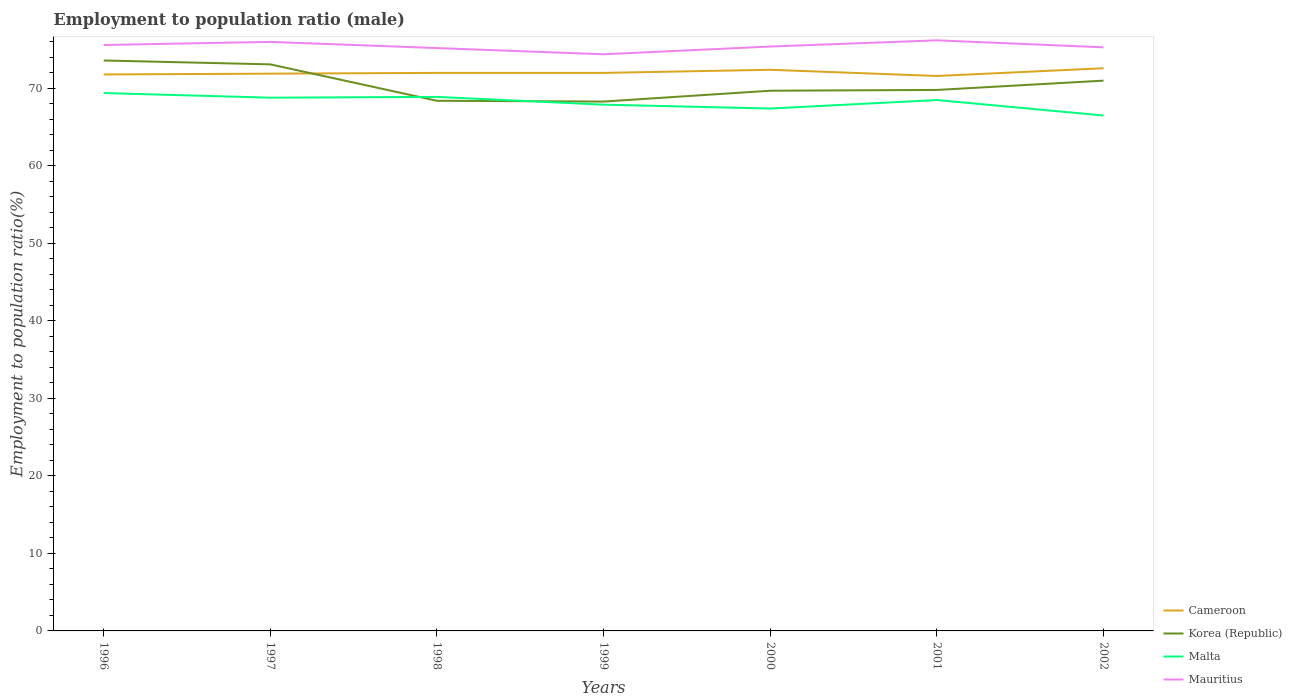How many different coloured lines are there?
Keep it short and to the point. 4. Is the number of lines equal to the number of legend labels?
Your response must be concise. Yes. Across all years, what is the maximum employment to population ratio in Malta?
Your answer should be very brief. 66.5. What is the total employment to population ratio in Mauritius in the graph?
Your answer should be compact. 0.9. What is the difference between the highest and the lowest employment to population ratio in Korea (Republic)?
Your answer should be compact. 3. What is the difference between two consecutive major ticks on the Y-axis?
Provide a succinct answer. 10. Are the values on the major ticks of Y-axis written in scientific E-notation?
Offer a very short reply. No. Does the graph contain any zero values?
Your answer should be very brief. No. Does the graph contain grids?
Provide a short and direct response. No. Where does the legend appear in the graph?
Your answer should be compact. Bottom right. What is the title of the graph?
Offer a very short reply. Employment to population ratio (male). Does "Dominica" appear as one of the legend labels in the graph?
Ensure brevity in your answer.  No. What is the label or title of the X-axis?
Offer a terse response. Years. What is the Employment to population ratio(%) in Cameroon in 1996?
Your response must be concise. 71.8. What is the Employment to population ratio(%) of Korea (Republic) in 1996?
Your answer should be very brief. 73.6. What is the Employment to population ratio(%) of Malta in 1996?
Your answer should be very brief. 69.4. What is the Employment to population ratio(%) of Mauritius in 1996?
Your answer should be very brief. 75.6. What is the Employment to population ratio(%) of Cameroon in 1997?
Ensure brevity in your answer.  71.9. What is the Employment to population ratio(%) of Korea (Republic) in 1997?
Offer a terse response. 73.1. What is the Employment to population ratio(%) in Malta in 1997?
Provide a short and direct response. 68.8. What is the Employment to population ratio(%) of Mauritius in 1997?
Offer a terse response. 76. What is the Employment to population ratio(%) of Cameroon in 1998?
Offer a very short reply. 72. What is the Employment to population ratio(%) in Korea (Republic) in 1998?
Keep it short and to the point. 68.4. What is the Employment to population ratio(%) in Malta in 1998?
Offer a very short reply. 68.9. What is the Employment to population ratio(%) in Mauritius in 1998?
Make the answer very short. 75.2. What is the Employment to population ratio(%) in Korea (Republic) in 1999?
Give a very brief answer. 68.3. What is the Employment to population ratio(%) of Malta in 1999?
Offer a very short reply. 67.9. What is the Employment to population ratio(%) in Mauritius in 1999?
Offer a terse response. 74.4. What is the Employment to population ratio(%) of Cameroon in 2000?
Ensure brevity in your answer.  72.4. What is the Employment to population ratio(%) in Korea (Republic) in 2000?
Give a very brief answer. 69.7. What is the Employment to population ratio(%) in Malta in 2000?
Your response must be concise. 67.4. What is the Employment to population ratio(%) in Mauritius in 2000?
Make the answer very short. 75.4. What is the Employment to population ratio(%) in Cameroon in 2001?
Ensure brevity in your answer.  71.6. What is the Employment to population ratio(%) of Korea (Republic) in 2001?
Your answer should be compact. 69.8. What is the Employment to population ratio(%) in Malta in 2001?
Your answer should be compact. 68.5. What is the Employment to population ratio(%) of Mauritius in 2001?
Give a very brief answer. 76.2. What is the Employment to population ratio(%) of Cameroon in 2002?
Your response must be concise. 72.6. What is the Employment to population ratio(%) of Malta in 2002?
Provide a succinct answer. 66.5. What is the Employment to population ratio(%) in Mauritius in 2002?
Make the answer very short. 75.3. Across all years, what is the maximum Employment to population ratio(%) of Cameroon?
Your response must be concise. 72.6. Across all years, what is the maximum Employment to population ratio(%) of Korea (Republic)?
Give a very brief answer. 73.6. Across all years, what is the maximum Employment to population ratio(%) in Malta?
Give a very brief answer. 69.4. Across all years, what is the maximum Employment to population ratio(%) of Mauritius?
Give a very brief answer. 76.2. Across all years, what is the minimum Employment to population ratio(%) of Cameroon?
Keep it short and to the point. 71.6. Across all years, what is the minimum Employment to population ratio(%) of Korea (Republic)?
Your answer should be compact. 68.3. Across all years, what is the minimum Employment to population ratio(%) in Malta?
Your answer should be very brief. 66.5. Across all years, what is the minimum Employment to population ratio(%) of Mauritius?
Your answer should be very brief. 74.4. What is the total Employment to population ratio(%) in Cameroon in the graph?
Offer a very short reply. 504.3. What is the total Employment to population ratio(%) of Korea (Republic) in the graph?
Give a very brief answer. 493.9. What is the total Employment to population ratio(%) in Malta in the graph?
Provide a short and direct response. 477.4. What is the total Employment to population ratio(%) of Mauritius in the graph?
Provide a succinct answer. 528.1. What is the difference between the Employment to population ratio(%) of Cameroon in 1996 and that in 1997?
Your answer should be compact. -0.1. What is the difference between the Employment to population ratio(%) of Mauritius in 1996 and that in 1997?
Offer a very short reply. -0.4. What is the difference between the Employment to population ratio(%) in Cameroon in 1996 and that in 1998?
Keep it short and to the point. -0.2. What is the difference between the Employment to population ratio(%) in Malta in 1996 and that in 1998?
Give a very brief answer. 0.5. What is the difference between the Employment to population ratio(%) of Mauritius in 1996 and that in 1998?
Provide a succinct answer. 0.4. What is the difference between the Employment to population ratio(%) in Cameroon in 1996 and that in 2001?
Provide a succinct answer. 0.2. What is the difference between the Employment to population ratio(%) of Malta in 1996 and that in 2001?
Your response must be concise. 0.9. What is the difference between the Employment to population ratio(%) of Mauritius in 1996 and that in 2001?
Offer a terse response. -0.6. What is the difference between the Employment to population ratio(%) in Malta in 1996 and that in 2002?
Your response must be concise. 2.9. What is the difference between the Employment to population ratio(%) in Cameroon in 1997 and that in 1998?
Offer a terse response. -0.1. What is the difference between the Employment to population ratio(%) of Malta in 1997 and that in 1998?
Offer a very short reply. -0.1. What is the difference between the Employment to population ratio(%) of Cameroon in 1997 and that in 1999?
Offer a very short reply. -0.1. What is the difference between the Employment to population ratio(%) of Korea (Republic) in 1997 and that in 1999?
Provide a short and direct response. 4.8. What is the difference between the Employment to population ratio(%) in Mauritius in 1997 and that in 1999?
Your response must be concise. 1.6. What is the difference between the Employment to population ratio(%) in Cameroon in 1997 and that in 2000?
Your answer should be compact. -0.5. What is the difference between the Employment to population ratio(%) in Malta in 1997 and that in 2000?
Make the answer very short. 1.4. What is the difference between the Employment to population ratio(%) of Korea (Republic) in 1997 and that in 2001?
Ensure brevity in your answer.  3.3. What is the difference between the Employment to population ratio(%) in Malta in 1997 and that in 2001?
Your answer should be very brief. 0.3. What is the difference between the Employment to population ratio(%) in Korea (Republic) in 1997 and that in 2002?
Your response must be concise. 2.1. What is the difference between the Employment to population ratio(%) of Korea (Republic) in 1998 and that in 1999?
Keep it short and to the point. 0.1. What is the difference between the Employment to population ratio(%) in Malta in 1998 and that in 1999?
Provide a short and direct response. 1. What is the difference between the Employment to population ratio(%) of Korea (Republic) in 1998 and that in 2000?
Offer a terse response. -1.3. What is the difference between the Employment to population ratio(%) in Malta in 1998 and that in 2000?
Give a very brief answer. 1.5. What is the difference between the Employment to population ratio(%) of Mauritius in 1998 and that in 2000?
Offer a terse response. -0.2. What is the difference between the Employment to population ratio(%) of Cameroon in 1998 and that in 2001?
Make the answer very short. 0.4. What is the difference between the Employment to population ratio(%) in Malta in 1998 and that in 2001?
Make the answer very short. 0.4. What is the difference between the Employment to population ratio(%) in Cameroon in 1998 and that in 2002?
Your answer should be very brief. -0.6. What is the difference between the Employment to population ratio(%) in Korea (Republic) in 1998 and that in 2002?
Your response must be concise. -2.6. What is the difference between the Employment to population ratio(%) of Mauritius in 1998 and that in 2002?
Your response must be concise. -0.1. What is the difference between the Employment to population ratio(%) in Cameroon in 1999 and that in 2000?
Your response must be concise. -0.4. What is the difference between the Employment to population ratio(%) of Korea (Republic) in 1999 and that in 2000?
Keep it short and to the point. -1.4. What is the difference between the Employment to population ratio(%) of Malta in 1999 and that in 2000?
Make the answer very short. 0.5. What is the difference between the Employment to population ratio(%) in Mauritius in 1999 and that in 2000?
Ensure brevity in your answer.  -1. What is the difference between the Employment to population ratio(%) in Korea (Republic) in 1999 and that in 2002?
Keep it short and to the point. -2.7. What is the difference between the Employment to population ratio(%) in Mauritius in 1999 and that in 2002?
Provide a succinct answer. -0.9. What is the difference between the Employment to population ratio(%) in Malta in 2000 and that in 2001?
Give a very brief answer. -1.1. What is the difference between the Employment to population ratio(%) in Mauritius in 2000 and that in 2001?
Your response must be concise. -0.8. What is the difference between the Employment to population ratio(%) in Cameroon in 2000 and that in 2002?
Your answer should be compact. -0.2. What is the difference between the Employment to population ratio(%) in Malta in 2000 and that in 2002?
Offer a terse response. 0.9. What is the difference between the Employment to population ratio(%) of Mauritius in 2000 and that in 2002?
Give a very brief answer. 0.1. What is the difference between the Employment to population ratio(%) in Cameroon in 2001 and that in 2002?
Ensure brevity in your answer.  -1. What is the difference between the Employment to population ratio(%) in Mauritius in 2001 and that in 2002?
Offer a very short reply. 0.9. What is the difference between the Employment to population ratio(%) of Cameroon in 1996 and the Employment to population ratio(%) of Korea (Republic) in 1997?
Provide a succinct answer. -1.3. What is the difference between the Employment to population ratio(%) in Cameroon in 1996 and the Employment to population ratio(%) in Malta in 1997?
Offer a terse response. 3. What is the difference between the Employment to population ratio(%) in Korea (Republic) in 1996 and the Employment to population ratio(%) in Mauritius in 1997?
Offer a terse response. -2.4. What is the difference between the Employment to population ratio(%) of Cameroon in 1996 and the Employment to population ratio(%) of Malta in 1998?
Offer a very short reply. 2.9. What is the difference between the Employment to population ratio(%) in Korea (Republic) in 1996 and the Employment to population ratio(%) in Mauritius in 1998?
Offer a very short reply. -1.6. What is the difference between the Employment to population ratio(%) in Malta in 1996 and the Employment to population ratio(%) in Mauritius in 1998?
Your response must be concise. -5.8. What is the difference between the Employment to population ratio(%) in Cameroon in 1996 and the Employment to population ratio(%) in Malta in 1999?
Your response must be concise. 3.9. What is the difference between the Employment to population ratio(%) of Cameroon in 1996 and the Employment to population ratio(%) of Korea (Republic) in 2000?
Make the answer very short. 2.1. What is the difference between the Employment to population ratio(%) in Cameroon in 1996 and the Employment to population ratio(%) in Malta in 2000?
Ensure brevity in your answer.  4.4. What is the difference between the Employment to population ratio(%) of Cameroon in 1996 and the Employment to population ratio(%) of Mauritius in 2000?
Provide a succinct answer. -3.6. What is the difference between the Employment to population ratio(%) of Korea (Republic) in 1996 and the Employment to population ratio(%) of Mauritius in 2000?
Provide a short and direct response. -1.8. What is the difference between the Employment to population ratio(%) of Cameroon in 1996 and the Employment to population ratio(%) of Korea (Republic) in 2001?
Your answer should be compact. 2. What is the difference between the Employment to population ratio(%) in Cameroon in 1996 and the Employment to population ratio(%) in Malta in 2001?
Your answer should be very brief. 3.3. What is the difference between the Employment to population ratio(%) of Cameroon in 1996 and the Employment to population ratio(%) of Mauritius in 2001?
Your response must be concise. -4.4. What is the difference between the Employment to population ratio(%) in Malta in 1996 and the Employment to population ratio(%) in Mauritius in 2001?
Offer a terse response. -6.8. What is the difference between the Employment to population ratio(%) of Cameroon in 1996 and the Employment to population ratio(%) of Korea (Republic) in 2002?
Keep it short and to the point. 0.8. What is the difference between the Employment to population ratio(%) in Cameroon in 1996 and the Employment to population ratio(%) in Malta in 2002?
Offer a terse response. 5.3. What is the difference between the Employment to population ratio(%) in Cameroon in 1996 and the Employment to population ratio(%) in Mauritius in 2002?
Give a very brief answer. -3.5. What is the difference between the Employment to population ratio(%) in Malta in 1996 and the Employment to population ratio(%) in Mauritius in 2002?
Your answer should be very brief. -5.9. What is the difference between the Employment to population ratio(%) in Cameroon in 1997 and the Employment to population ratio(%) in Korea (Republic) in 1998?
Offer a very short reply. 3.5. What is the difference between the Employment to population ratio(%) of Korea (Republic) in 1997 and the Employment to population ratio(%) of Mauritius in 1998?
Offer a very short reply. -2.1. What is the difference between the Employment to population ratio(%) in Malta in 1997 and the Employment to population ratio(%) in Mauritius in 1998?
Provide a short and direct response. -6.4. What is the difference between the Employment to population ratio(%) in Cameroon in 1997 and the Employment to population ratio(%) in Korea (Republic) in 1999?
Your response must be concise. 3.6. What is the difference between the Employment to population ratio(%) in Cameroon in 1997 and the Employment to population ratio(%) in Malta in 1999?
Give a very brief answer. 4. What is the difference between the Employment to population ratio(%) in Cameroon in 1997 and the Employment to population ratio(%) in Mauritius in 1999?
Give a very brief answer. -2.5. What is the difference between the Employment to population ratio(%) in Korea (Republic) in 1997 and the Employment to population ratio(%) in Mauritius in 1999?
Keep it short and to the point. -1.3. What is the difference between the Employment to population ratio(%) in Malta in 1997 and the Employment to population ratio(%) in Mauritius in 1999?
Offer a terse response. -5.6. What is the difference between the Employment to population ratio(%) of Cameroon in 1997 and the Employment to population ratio(%) of Malta in 2000?
Offer a terse response. 4.5. What is the difference between the Employment to population ratio(%) of Cameroon in 1997 and the Employment to population ratio(%) of Mauritius in 2000?
Your response must be concise. -3.5. What is the difference between the Employment to population ratio(%) of Korea (Republic) in 1997 and the Employment to population ratio(%) of Mauritius in 2000?
Offer a very short reply. -2.3. What is the difference between the Employment to population ratio(%) in Malta in 1997 and the Employment to population ratio(%) in Mauritius in 2000?
Give a very brief answer. -6.6. What is the difference between the Employment to population ratio(%) in Cameroon in 1997 and the Employment to population ratio(%) in Mauritius in 2001?
Offer a very short reply. -4.3. What is the difference between the Employment to population ratio(%) in Korea (Republic) in 1997 and the Employment to population ratio(%) in Malta in 2001?
Provide a succinct answer. 4.6. What is the difference between the Employment to population ratio(%) in Malta in 1997 and the Employment to population ratio(%) in Mauritius in 2001?
Ensure brevity in your answer.  -7.4. What is the difference between the Employment to population ratio(%) of Cameroon in 1997 and the Employment to population ratio(%) of Malta in 2002?
Give a very brief answer. 5.4. What is the difference between the Employment to population ratio(%) of Cameroon in 1997 and the Employment to population ratio(%) of Mauritius in 2002?
Offer a terse response. -3.4. What is the difference between the Employment to population ratio(%) in Korea (Republic) in 1997 and the Employment to population ratio(%) in Malta in 2002?
Make the answer very short. 6.6. What is the difference between the Employment to population ratio(%) of Korea (Republic) in 1998 and the Employment to population ratio(%) of Malta in 1999?
Your answer should be compact. 0.5. What is the difference between the Employment to population ratio(%) of Malta in 1998 and the Employment to population ratio(%) of Mauritius in 1999?
Offer a terse response. -5.5. What is the difference between the Employment to population ratio(%) in Cameroon in 1998 and the Employment to population ratio(%) in Korea (Republic) in 2000?
Give a very brief answer. 2.3. What is the difference between the Employment to population ratio(%) of Cameroon in 1998 and the Employment to population ratio(%) of Malta in 2000?
Ensure brevity in your answer.  4.6. What is the difference between the Employment to population ratio(%) of Korea (Republic) in 1998 and the Employment to population ratio(%) of Mauritius in 2000?
Your response must be concise. -7. What is the difference between the Employment to population ratio(%) of Malta in 1998 and the Employment to population ratio(%) of Mauritius in 2000?
Ensure brevity in your answer.  -6.5. What is the difference between the Employment to population ratio(%) in Cameroon in 1998 and the Employment to population ratio(%) in Malta in 2001?
Your answer should be very brief. 3.5. What is the difference between the Employment to population ratio(%) in Cameroon in 1998 and the Employment to population ratio(%) in Mauritius in 2001?
Provide a short and direct response. -4.2. What is the difference between the Employment to population ratio(%) in Korea (Republic) in 1998 and the Employment to population ratio(%) in Malta in 2001?
Your response must be concise. -0.1. What is the difference between the Employment to population ratio(%) of Korea (Republic) in 1998 and the Employment to population ratio(%) of Mauritius in 2001?
Your answer should be compact. -7.8. What is the difference between the Employment to population ratio(%) in Cameroon in 1998 and the Employment to population ratio(%) in Malta in 2002?
Provide a short and direct response. 5.5. What is the difference between the Employment to population ratio(%) in Cameroon in 1998 and the Employment to population ratio(%) in Mauritius in 2002?
Provide a short and direct response. -3.3. What is the difference between the Employment to population ratio(%) of Cameroon in 1999 and the Employment to population ratio(%) of Mauritius in 2000?
Provide a succinct answer. -3.4. What is the difference between the Employment to population ratio(%) of Korea (Republic) in 1999 and the Employment to population ratio(%) of Malta in 2000?
Your answer should be very brief. 0.9. What is the difference between the Employment to population ratio(%) of Cameroon in 1999 and the Employment to population ratio(%) of Korea (Republic) in 2001?
Keep it short and to the point. 2.2. What is the difference between the Employment to population ratio(%) of Cameroon in 1999 and the Employment to population ratio(%) of Malta in 2001?
Your response must be concise. 3.5. What is the difference between the Employment to population ratio(%) of Korea (Republic) in 1999 and the Employment to population ratio(%) of Mauritius in 2001?
Keep it short and to the point. -7.9. What is the difference between the Employment to population ratio(%) of Malta in 1999 and the Employment to population ratio(%) of Mauritius in 2001?
Your answer should be very brief. -8.3. What is the difference between the Employment to population ratio(%) of Cameroon in 1999 and the Employment to population ratio(%) of Korea (Republic) in 2002?
Your answer should be very brief. 1. What is the difference between the Employment to population ratio(%) of Cameroon in 1999 and the Employment to population ratio(%) of Malta in 2002?
Your answer should be compact. 5.5. What is the difference between the Employment to population ratio(%) in Cameroon in 1999 and the Employment to population ratio(%) in Mauritius in 2002?
Provide a succinct answer. -3.3. What is the difference between the Employment to population ratio(%) in Korea (Republic) in 1999 and the Employment to population ratio(%) in Mauritius in 2002?
Ensure brevity in your answer.  -7. What is the difference between the Employment to population ratio(%) of Malta in 1999 and the Employment to population ratio(%) of Mauritius in 2002?
Provide a short and direct response. -7.4. What is the difference between the Employment to population ratio(%) in Cameroon in 2000 and the Employment to population ratio(%) in Korea (Republic) in 2001?
Provide a short and direct response. 2.6. What is the difference between the Employment to population ratio(%) in Cameroon in 2000 and the Employment to population ratio(%) in Malta in 2001?
Offer a terse response. 3.9. What is the difference between the Employment to population ratio(%) of Korea (Republic) in 2000 and the Employment to population ratio(%) of Malta in 2001?
Offer a very short reply. 1.2. What is the difference between the Employment to population ratio(%) of Korea (Republic) in 2000 and the Employment to population ratio(%) of Mauritius in 2001?
Provide a short and direct response. -6.5. What is the difference between the Employment to population ratio(%) in Cameroon in 2000 and the Employment to population ratio(%) in Malta in 2002?
Offer a terse response. 5.9. What is the difference between the Employment to population ratio(%) of Korea (Republic) in 2000 and the Employment to population ratio(%) of Mauritius in 2002?
Your response must be concise. -5.6. What is the difference between the Employment to population ratio(%) of Korea (Republic) in 2001 and the Employment to population ratio(%) of Mauritius in 2002?
Offer a very short reply. -5.5. What is the difference between the Employment to population ratio(%) in Malta in 2001 and the Employment to population ratio(%) in Mauritius in 2002?
Provide a short and direct response. -6.8. What is the average Employment to population ratio(%) of Cameroon per year?
Provide a short and direct response. 72.04. What is the average Employment to population ratio(%) in Korea (Republic) per year?
Keep it short and to the point. 70.56. What is the average Employment to population ratio(%) of Malta per year?
Make the answer very short. 68.2. What is the average Employment to population ratio(%) of Mauritius per year?
Your response must be concise. 75.44. In the year 1996, what is the difference between the Employment to population ratio(%) in Korea (Republic) and Employment to population ratio(%) in Mauritius?
Ensure brevity in your answer.  -2. In the year 1997, what is the difference between the Employment to population ratio(%) of Cameroon and Employment to population ratio(%) of Korea (Republic)?
Provide a short and direct response. -1.2. In the year 1997, what is the difference between the Employment to population ratio(%) in Cameroon and Employment to population ratio(%) in Malta?
Provide a succinct answer. 3.1. In the year 1997, what is the difference between the Employment to population ratio(%) in Korea (Republic) and Employment to population ratio(%) in Mauritius?
Your response must be concise. -2.9. In the year 1998, what is the difference between the Employment to population ratio(%) of Cameroon and Employment to population ratio(%) of Korea (Republic)?
Keep it short and to the point. 3.6. In the year 1998, what is the difference between the Employment to population ratio(%) of Cameroon and Employment to population ratio(%) of Malta?
Keep it short and to the point. 3.1. In the year 1998, what is the difference between the Employment to population ratio(%) of Cameroon and Employment to population ratio(%) of Mauritius?
Keep it short and to the point. -3.2. In the year 1998, what is the difference between the Employment to population ratio(%) of Korea (Republic) and Employment to population ratio(%) of Malta?
Keep it short and to the point. -0.5. In the year 1998, what is the difference between the Employment to population ratio(%) in Malta and Employment to population ratio(%) in Mauritius?
Offer a terse response. -6.3. In the year 1999, what is the difference between the Employment to population ratio(%) in Cameroon and Employment to population ratio(%) in Korea (Republic)?
Your answer should be very brief. 3.7. In the year 1999, what is the difference between the Employment to population ratio(%) of Cameroon and Employment to population ratio(%) of Mauritius?
Your answer should be compact. -2.4. In the year 1999, what is the difference between the Employment to population ratio(%) of Korea (Republic) and Employment to population ratio(%) of Mauritius?
Keep it short and to the point. -6.1. In the year 1999, what is the difference between the Employment to population ratio(%) in Malta and Employment to population ratio(%) in Mauritius?
Offer a very short reply. -6.5. In the year 2000, what is the difference between the Employment to population ratio(%) of Cameroon and Employment to population ratio(%) of Korea (Republic)?
Provide a short and direct response. 2.7. In the year 2000, what is the difference between the Employment to population ratio(%) in Cameroon and Employment to population ratio(%) in Malta?
Keep it short and to the point. 5. In the year 2000, what is the difference between the Employment to population ratio(%) of Cameroon and Employment to population ratio(%) of Mauritius?
Provide a short and direct response. -3. In the year 2000, what is the difference between the Employment to population ratio(%) of Korea (Republic) and Employment to population ratio(%) of Malta?
Make the answer very short. 2.3. In the year 2000, what is the difference between the Employment to population ratio(%) in Malta and Employment to population ratio(%) in Mauritius?
Ensure brevity in your answer.  -8. In the year 2002, what is the difference between the Employment to population ratio(%) in Cameroon and Employment to population ratio(%) in Malta?
Provide a succinct answer. 6.1. In the year 2002, what is the difference between the Employment to population ratio(%) in Korea (Republic) and Employment to population ratio(%) in Malta?
Offer a very short reply. 4.5. In the year 2002, what is the difference between the Employment to population ratio(%) of Korea (Republic) and Employment to population ratio(%) of Mauritius?
Your answer should be compact. -4.3. In the year 2002, what is the difference between the Employment to population ratio(%) in Malta and Employment to population ratio(%) in Mauritius?
Offer a very short reply. -8.8. What is the ratio of the Employment to population ratio(%) in Korea (Republic) in 1996 to that in 1997?
Your answer should be very brief. 1.01. What is the ratio of the Employment to population ratio(%) in Malta in 1996 to that in 1997?
Offer a terse response. 1.01. What is the ratio of the Employment to population ratio(%) of Mauritius in 1996 to that in 1997?
Your answer should be compact. 0.99. What is the ratio of the Employment to population ratio(%) in Korea (Republic) in 1996 to that in 1998?
Provide a short and direct response. 1.08. What is the ratio of the Employment to population ratio(%) in Malta in 1996 to that in 1998?
Provide a short and direct response. 1.01. What is the ratio of the Employment to population ratio(%) of Cameroon in 1996 to that in 1999?
Make the answer very short. 1. What is the ratio of the Employment to population ratio(%) in Korea (Republic) in 1996 to that in 1999?
Your response must be concise. 1.08. What is the ratio of the Employment to population ratio(%) of Malta in 1996 to that in 1999?
Offer a terse response. 1.02. What is the ratio of the Employment to population ratio(%) in Mauritius in 1996 to that in 1999?
Offer a terse response. 1.02. What is the ratio of the Employment to population ratio(%) of Cameroon in 1996 to that in 2000?
Offer a very short reply. 0.99. What is the ratio of the Employment to population ratio(%) in Korea (Republic) in 1996 to that in 2000?
Provide a short and direct response. 1.06. What is the ratio of the Employment to population ratio(%) in Malta in 1996 to that in 2000?
Your answer should be compact. 1.03. What is the ratio of the Employment to population ratio(%) in Cameroon in 1996 to that in 2001?
Ensure brevity in your answer.  1. What is the ratio of the Employment to population ratio(%) of Korea (Republic) in 1996 to that in 2001?
Offer a very short reply. 1.05. What is the ratio of the Employment to population ratio(%) of Malta in 1996 to that in 2001?
Ensure brevity in your answer.  1.01. What is the ratio of the Employment to population ratio(%) of Mauritius in 1996 to that in 2001?
Make the answer very short. 0.99. What is the ratio of the Employment to population ratio(%) of Korea (Republic) in 1996 to that in 2002?
Provide a short and direct response. 1.04. What is the ratio of the Employment to population ratio(%) of Malta in 1996 to that in 2002?
Your answer should be very brief. 1.04. What is the ratio of the Employment to population ratio(%) of Mauritius in 1996 to that in 2002?
Offer a terse response. 1. What is the ratio of the Employment to population ratio(%) in Cameroon in 1997 to that in 1998?
Give a very brief answer. 1. What is the ratio of the Employment to population ratio(%) in Korea (Republic) in 1997 to that in 1998?
Your response must be concise. 1.07. What is the ratio of the Employment to population ratio(%) of Malta in 1997 to that in 1998?
Provide a succinct answer. 1. What is the ratio of the Employment to population ratio(%) of Mauritius in 1997 to that in 1998?
Provide a succinct answer. 1.01. What is the ratio of the Employment to population ratio(%) of Cameroon in 1997 to that in 1999?
Make the answer very short. 1. What is the ratio of the Employment to population ratio(%) of Korea (Republic) in 1997 to that in 1999?
Give a very brief answer. 1.07. What is the ratio of the Employment to population ratio(%) in Malta in 1997 to that in 1999?
Provide a short and direct response. 1.01. What is the ratio of the Employment to population ratio(%) in Mauritius in 1997 to that in 1999?
Offer a terse response. 1.02. What is the ratio of the Employment to population ratio(%) in Cameroon in 1997 to that in 2000?
Ensure brevity in your answer.  0.99. What is the ratio of the Employment to population ratio(%) of Korea (Republic) in 1997 to that in 2000?
Provide a short and direct response. 1.05. What is the ratio of the Employment to population ratio(%) in Malta in 1997 to that in 2000?
Make the answer very short. 1.02. What is the ratio of the Employment to population ratio(%) in Mauritius in 1997 to that in 2000?
Keep it short and to the point. 1.01. What is the ratio of the Employment to population ratio(%) of Cameroon in 1997 to that in 2001?
Your answer should be very brief. 1. What is the ratio of the Employment to population ratio(%) in Korea (Republic) in 1997 to that in 2001?
Provide a short and direct response. 1.05. What is the ratio of the Employment to population ratio(%) of Malta in 1997 to that in 2001?
Your response must be concise. 1. What is the ratio of the Employment to population ratio(%) in Mauritius in 1997 to that in 2001?
Ensure brevity in your answer.  1. What is the ratio of the Employment to population ratio(%) in Korea (Republic) in 1997 to that in 2002?
Your response must be concise. 1.03. What is the ratio of the Employment to population ratio(%) in Malta in 1997 to that in 2002?
Provide a short and direct response. 1.03. What is the ratio of the Employment to population ratio(%) in Mauritius in 1997 to that in 2002?
Keep it short and to the point. 1.01. What is the ratio of the Employment to population ratio(%) in Korea (Republic) in 1998 to that in 1999?
Ensure brevity in your answer.  1. What is the ratio of the Employment to population ratio(%) of Malta in 1998 to that in 1999?
Keep it short and to the point. 1.01. What is the ratio of the Employment to population ratio(%) in Mauritius in 1998 to that in 1999?
Keep it short and to the point. 1.01. What is the ratio of the Employment to population ratio(%) of Korea (Republic) in 1998 to that in 2000?
Make the answer very short. 0.98. What is the ratio of the Employment to population ratio(%) in Malta in 1998 to that in 2000?
Your answer should be compact. 1.02. What is the ratio of the Employment to population ratio(%) in Mauritius in 1998 to that in 2000?
Provide a succinct answer. 1. What is the ratio of the Employment to population ratio(%) of Cameroon in 1998 to that in 2001?
Keep it short and to the point. 1.01. What is the ratio of the Employment to population ratio(%) in Korea (Republic) in 1998 to that in 2001?
Your answer should be very brief. 0.98. What is the ratio of the Employment to population ratio(%) in Mauritius in 1998 to that in 2001?
Provide a succinct answer. 0.99. What is the ratio of the Employment to population ratio(%) of Korea (Republic) in 1998 to that in 2002?
Your answer should be compact. 0.96. What is the ratio of the Employment to population ratio(%) in Malta in 1998 to that in 2002?
Offer a very short reply. 1.04. What is the ratio of the Employment to population ratio(%) in Korea (Republic) in 1999 to that in 2000?
Provide a short and direct response. 0.98. What is the ratio of the Employment to population ratio(%) in Malta in 1999 to that in 2000?
Offer a terse response. 1.01. What is the ratio of the Employment to population ratio(%) of Mauritius in 1999 to that in 2000?
Give a very brief answer. 0.99. What is the ratio of the Employment to population ratio(%) of Cameroon in 1999 to that in 2001?
Provide a short and direct response. 1.01. What is the ratio of the Employment to population ratio(%) in Korea (Republic) in 1999 to that in 2001?
Offer a very short reply. 0.98. What is the ratio of the Employment to population ratio(%) of Mauritius in 1999 to that in 2001?
Your answer should be compact. 0.98. What is the ratio of the Employment to population ratio(%) in Cameroon in 1999 to that in 2002?
Your answer should be compact. 0.99. What is the ratio of the Employment to population ratio(%) in Malta in 1999 to that in 2002?
Provide a succinct answer. 1.02. What is the ratio of the Employment to population ratio(%) in Cameroon in 2000 to that in 2001?
Provide a succinct answer. 1.01. What is the ratio of the Employment to population ratio(%) of Korea (Republic) in 2000 to that in 2001?
Keep it short and to the point. 1. What is the ratio of the Employment to population ratio(%) in Malta in 2000 to that in 2001?
Offer a terse response. 0.98. What is the ratio of the Employment to population ratio(%) in Mauritius in 2000 to that in 2001?
Your answer should be compact. 0.99. What is the ratio of the Employment to population ratio(%) in Cameroon in 2000 to that in 2002?
Give a very brief answer. 1. What is the ratio of the Employment to population ratio(%) of Korea (Republic) in 2000 to that in 2002?
Provide a short and direct response. 0.98. What is the ratio of the Employment to population ratio(%) of Malta in 2000 to that in 2002?
Ensure brevity in your answer.  1.01. What is the ratio of the Employment to population ratio(%) of Cameroon in 2001 to that in 2002?
Provide a short and direct response. 0.99. What is the ratio of the Employment to population ratio(%) in Korea (Republic) in 2001 to that in 2002?
Give a very brief answer. 0.98. What is the ratio of the Employment to population ratio(%) of Malta in 2001 to that in 2002?
Offer a terse response. 1.03. What is the difference between the highest and the second highest Employment to population ratio(%) in Cameroon?
Give a very brief answer. 0.2. What is the difference between the highest and the second highest Employment to population ratio(%) of Malta?
Your response must be concise. 0.5. What is the difference between the highest and the lowest Employment to population ratio(%) in Cameroon?
Ensure brevity in your answer.  1. What is the difference between the highest and the lowest Employment to population ratio(%) in Korea (Republic)?
Your answer should be very brief. 5.3. What is the difference between the highest and the lowest Employment to population ratio(%) of Malta?
Your response must be concise. 2.9. What is the difference between the highest and the lowest Employment to population ratio(%) in Mauritius?
Offer a very short reply. 1.8. 